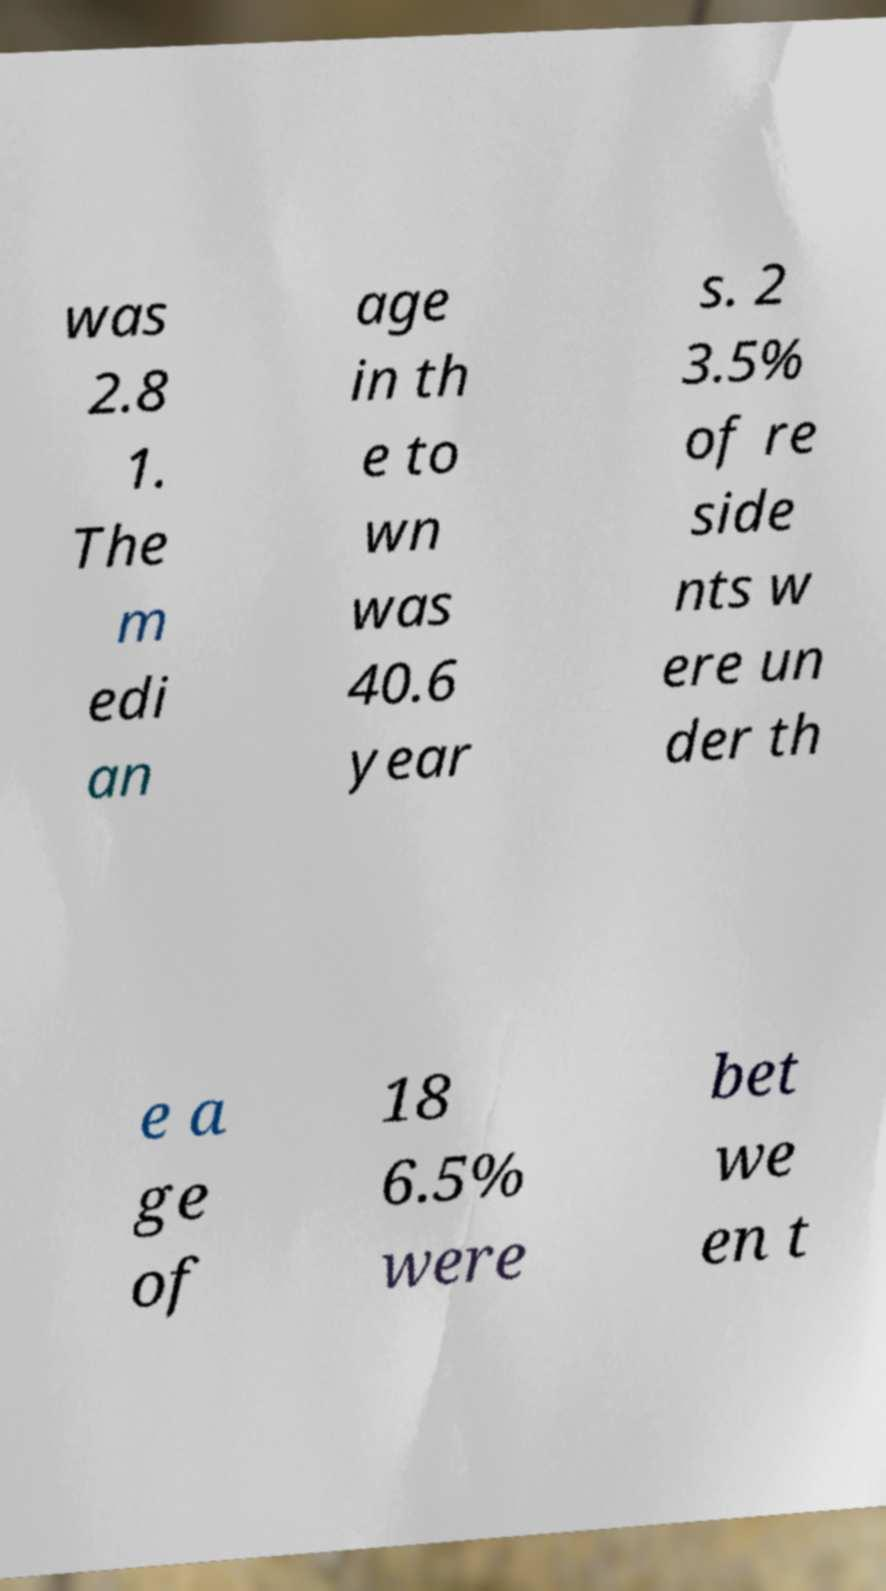I need the written content from this picture converted into text. Can you do that? was 2.8 1. The m edi an age in th e to wn was 40.6 year s. 2 3.5% of re side nts w ere un der th e a ge of 18 6.5% were bet we en t 